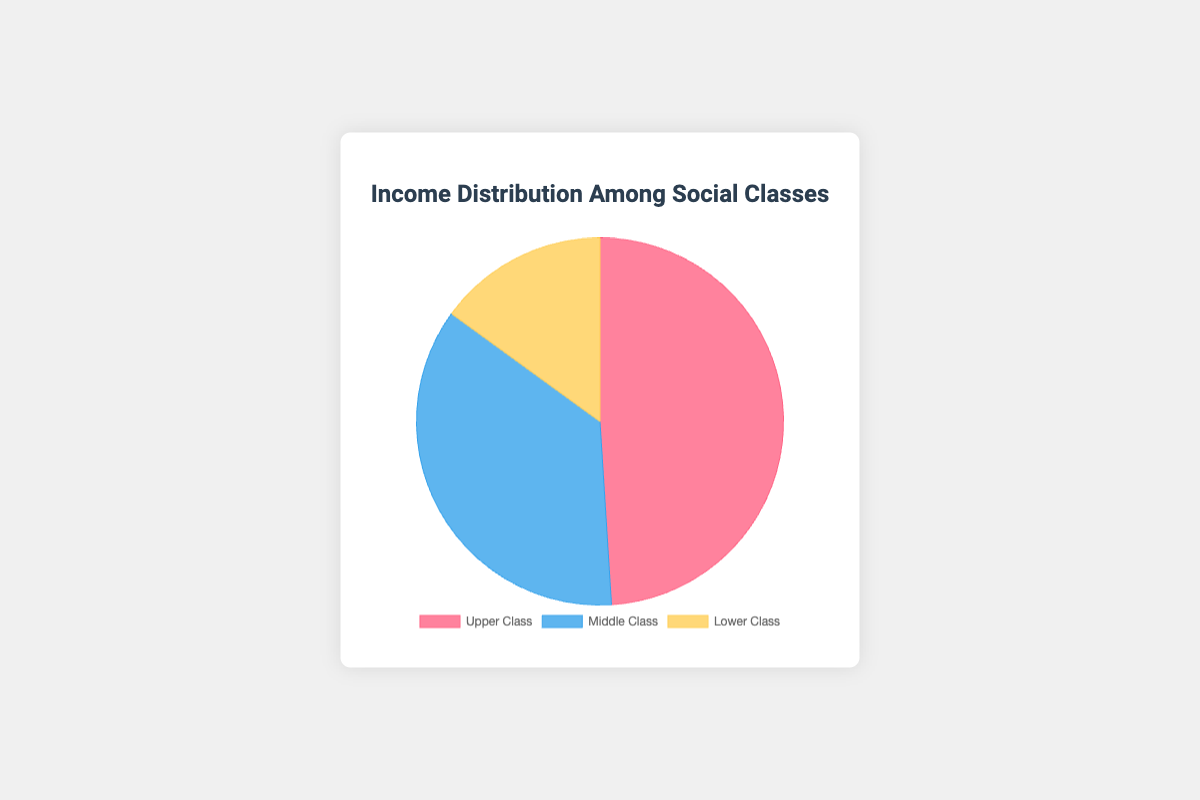What is the income share percentage of the Upper Class? The figure shows three data points representing income distribution among social classes. According to the figure, the income share percentage of the Upper Class is indicated directly.
Answer: 49% Which social class has the smallest income share? The pie chart displays different sections for each social class's income share. The Lower Class section is the smallest.
Answer: Lower Class How much higher is the income share of the Upper Class compared to the Lower Class? The pie chart shows that the Upper Class has an income share percentage of 49%, and the Lower Class has 15%. Subtracting these percentages gives the difference: 49% - 15%.
Answer: 34% What is the total combined income share of the Middle Class and Lower Class? The income shares of the Middle and Lower Classes are given as 36% and 15% respectively. Adding these percentages will give the total combined share: 36% + 15%.
Answer: 51% Which color is used to represent the Middle Class? The pie chart uses specific colors for each social class. By visually identifying the color corresponding to the Middle Class label, we can determine the color used. The Middle Class section is blue.
Answer: Blue Is the income share of the Middle Class greater or less than half of the total income share? The Middle Class income share is 36%. Since half of the total income share would be 50%, 36% is less than 50%.
Answer: Less What is the difference between the income shares of the Upper and Middle Classes? The pie chart shows the Upper Class income share as 49% and the Middle Class share as 36%. Subtracting these percentages will give the difference: 49% - 36%.
Answer: 13% If the Lower Class's income share increased by 10%, what would the new percentage be? The current Lower Class income share is 15%. Adding an increase of 10% results in a new share of 15% + 10%.
Answer: 25% Which social class takes up the most space in the pie chart? By observing the size of each section in the pie chart, it is evident that the Upper Class occupies the largest portion.
Answer: Upper Class 